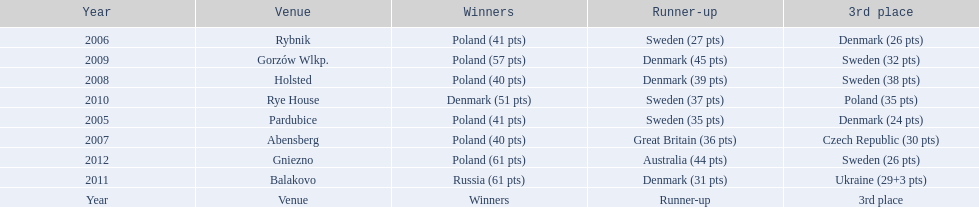Write the full table. {'header': ['Year', 'Venue', 'Winners', 'Runner-up', '3rd place'], 'rows': [['2006', 'Rybnik', 'Poland (41 pts)', 'Sweden (27 pts)', 'Denmark (26 pts)'], ['2009', 'Gorzów Wlkp.', 'Poland (57 pts)', 'Denmark (45 pts)', 'Sweden (32 pts)'], ['2008', 'Holsted', 'Poland (40 pts)', 'Denmark (39 pts)', 'Sweden (38 pts)'], ['2010', 'Rye House', 'Denmark (51 pts)', 'Sweden (37 pts)', 'Poland (35 pts)'], ['2005', 'Pardubice', 'Poland (41 pts)', 'Sweden (35 pts)', 'Denmark (24 pts)'], ['2007', 'Abensberg', 'Poland (40 pts)', 'Great Britain (36 pts)', 'Czech Republic (30 pts)'], ['2012', 'Gniezno', 'Poland (61 pts)', 'Australia (44 pts)', 'Sweden (26 pts)'], ['2011', 'Balakovo', 'Russia (61 pts)', 'Denmark (31 pts)', 'Ukraine (29+3 pts)'], ['Year', 'Venue', 'Winners', 'Runner-up', '3rd place']]} Did holland win the 2010 championship? if not who did? Rye House. What did position did holland they rank? 3rd place. 